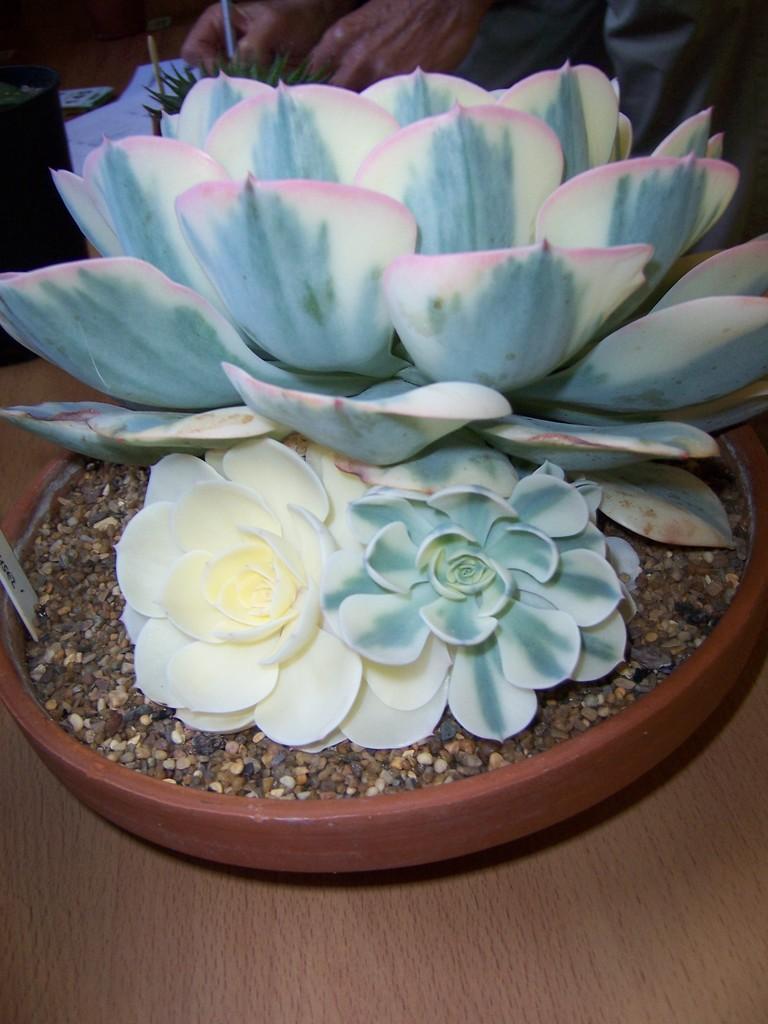Can you describe this image briefly? In the middle of the picture we can see flowers, soil in a flower pot. At the bottom it is table. At the top we can see a person, plant, paper and a black color object. 